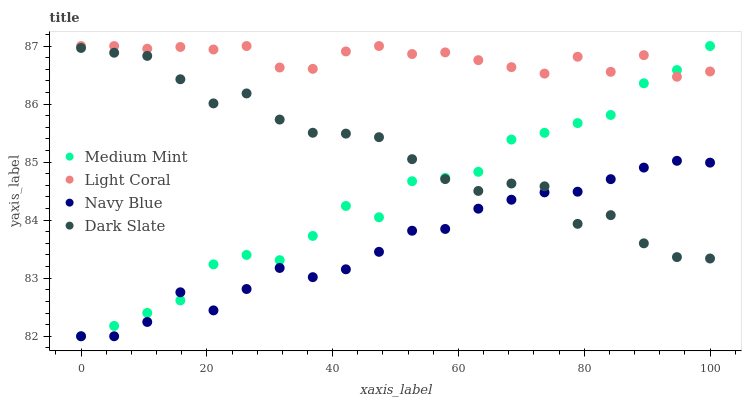Does Navy Blue have the minimum area under the curve?
Answer yes or no. Yes. Does Light Coral have the maximum area under the curve?
Answer yes or no. Yes. Does Dark Slate have the minimum area under the curve?
Answer yes or no. No. Does Dark Slate have the maximum area under the curve?
Answer yes or no. No. Is Navy Blue the smoothest?
Answer yes or no. Yes. Is Medium Mint the roughest?
Answer yes or no. Yes. Is Light Coral the smoothest?
Answer yes or no. No. Is Light Coral the roughest?
Answer yes or no. No. Does Medium Mint have the lowest value?
Answer yes or no. Yes. Does Dark Slate have the lowest value?
Answer yes or no. No. Does Light Coral have the highest value?
Answer yes or no. Yes. Does Dark Slate have the highest value?
Answer yes or no. No. Is Dark Slate less than Light Coral?
Answer yes or no. Yes. Is Light Coral greater than Dark Slate?
Answer yes or no. Yes. Does Dark Slate intersect Medium Mint?
Answer yes or no. Yes. Is Dark Slate less than Medium Mint?
Answer yes or no. No. Is Dark Slate greater than Medium Mint?
Answer yes or no. No. Does Dark Slate intersect Light Coral?
Answer yes or no. No. 